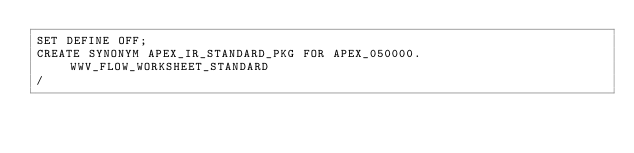Convert code to text. <code><loc_0><loc_0><loc_500><loc_500><_SQL_>SET DEFINE OFF;
CREATE SYNONYM APEX_IR_STANDARD_PKG FOR APEX_050000.WWV_FLOW_WORKSHEET_STANDARD
/
</code> 